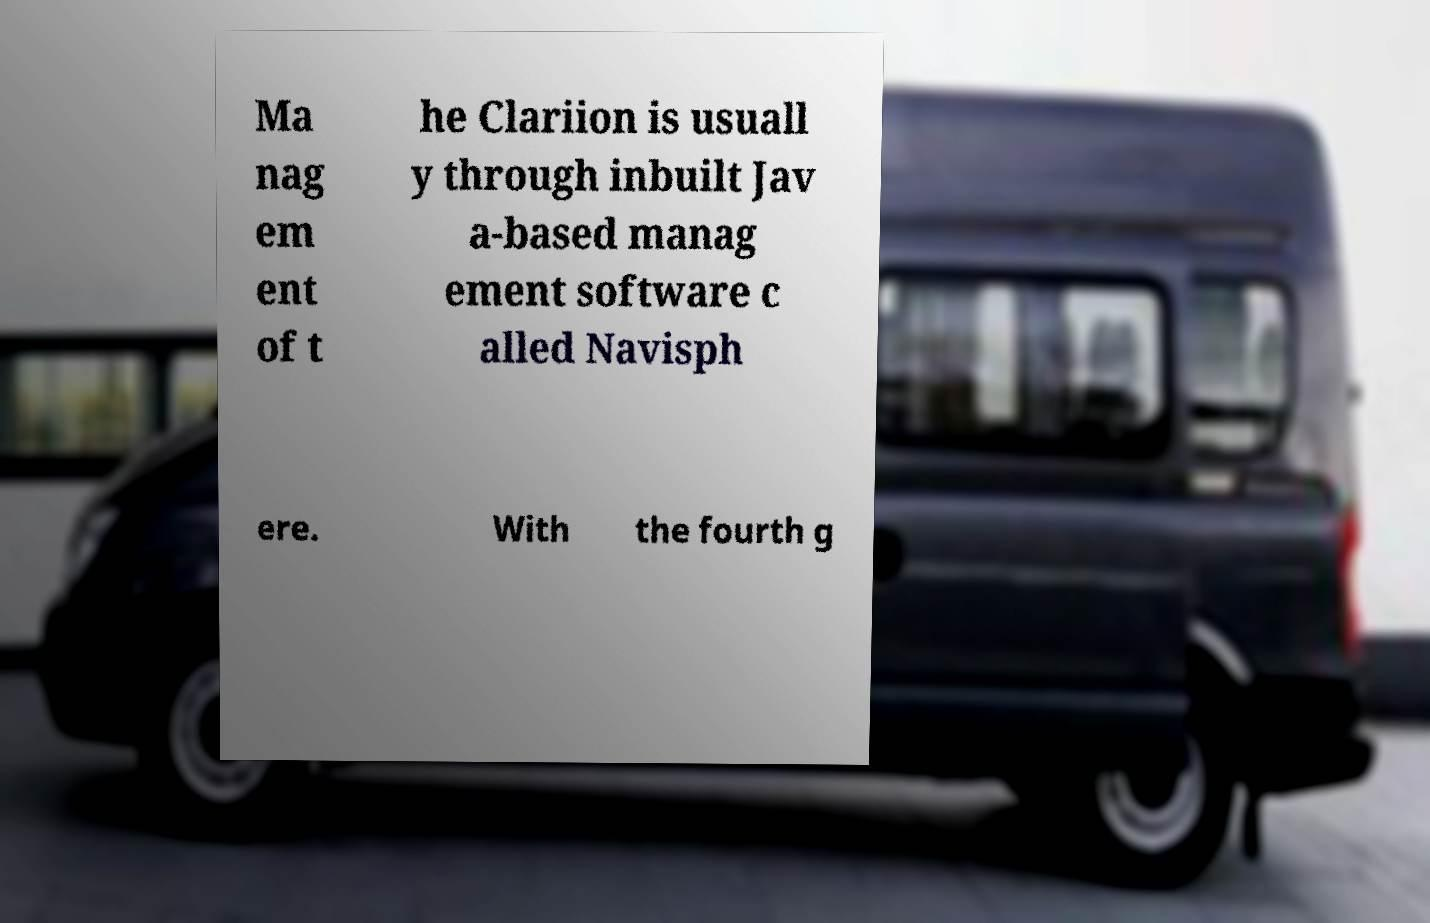What messages or text are displayed in this image? I need them in a readable, typed format. Ma nag em ent of t he Clariion is usuall y through inbuilt Jav a-based manag ement software c alled Navisph ere. With the fourth g 